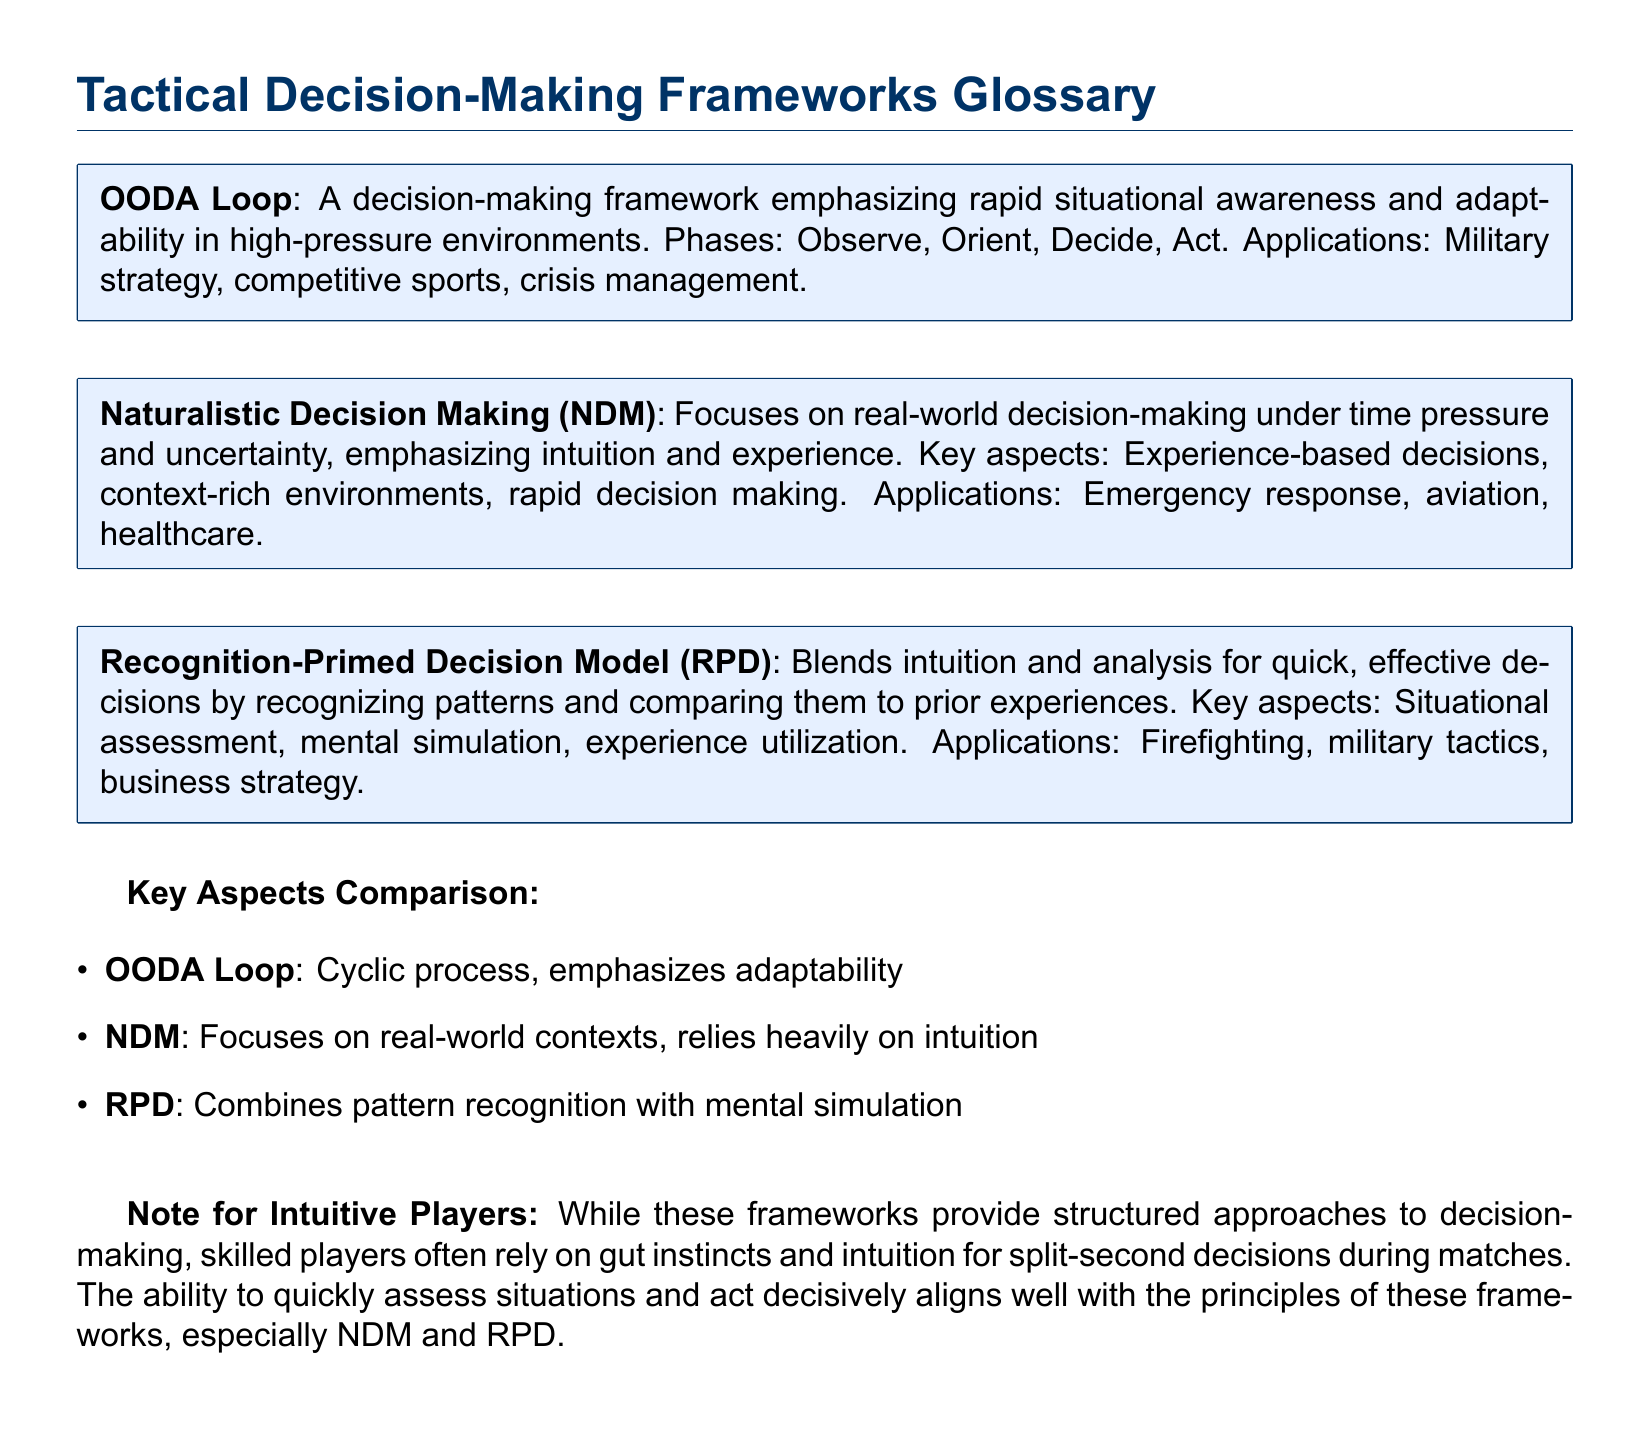What is the first phase of the OODA Loop? The OODA Loop consists of four phases, and the first one is Observe.
Answer: Observe Which decision-making framework emphasizes rapid situational awareness? The framework that emphasizes rapid situational awareness is the OODA Loop.
Answer: OODA Loop What does NDM stand for? The abbreviation NDM stands for Naturalistic Decision Making.
Answer: Naturalistic Decision Making Which model combines intuition and analysis? The model that combines intuition and analysis is the Recognition-Primed Decision Model.
Answer: Recognition-Primed Decision Model In which application is the Naturalistic Decision Making framework used? Naturalistic Decision Making is applied in emergency response.
Answer: Emergency response What are the key aspects of the Recognition-Primed Decision Model? The key aspects include situational assessment, mental simulation, and experience utilization.
Answer: Situational assessment, mental simulation, experience utilization Which tactical decision-making framework relies heavily on intuition? The framework that relies heavily on intuition is Naturalistic Decision Making.
Answer: Naturalistic Decision Making What is a notable feature of the OODA Loop process? A notable feature of the OODA Loop is its cyclic process.
Answer: Cyclic process How is decision-making described for intuitive players in the document? The document describes decision-making for intuitive players as reliant on gut instincts and intuition.
Answer: Gut instincts and intuition 